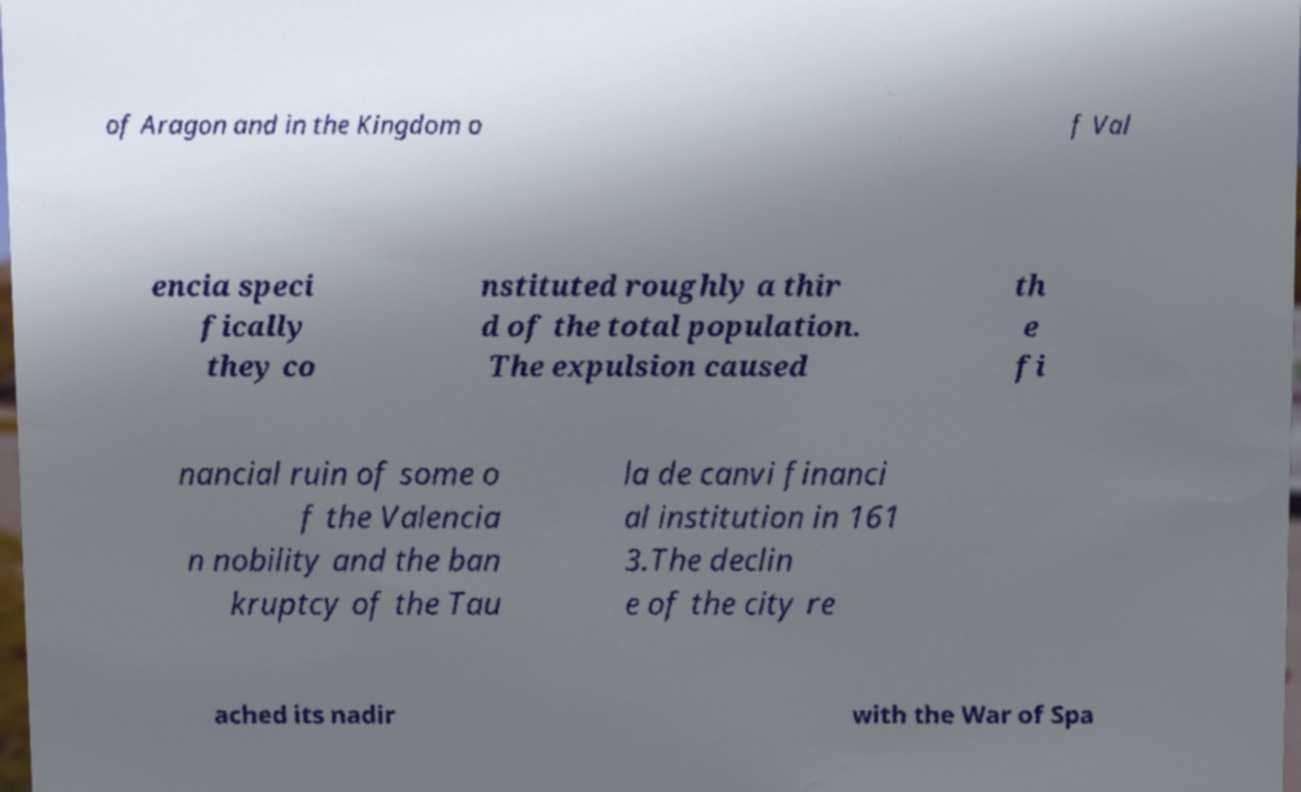Could you extract and type out the text from this image? of Aragon and in the Kingdom o f Val encia speci fically they co nstituted roughly a thir d of the total population. The expulsion caused th e fi nancial ruin of some o f the Valencia n nobility and the ban kruptcy of the Tau la de canvi financi al institution in 161 3.The declin e of the city re ached its nadir with the War of Spa 